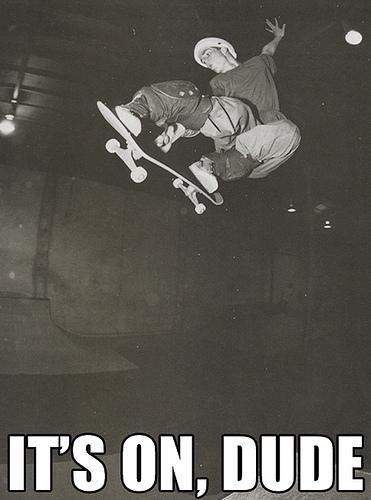What color do the wheels appear to be?
Keep it brief. White. Why is he wearing headgear?
Keep it brief. Protection. What are the words on the screen?
Concise answer only. It's on, dude. 